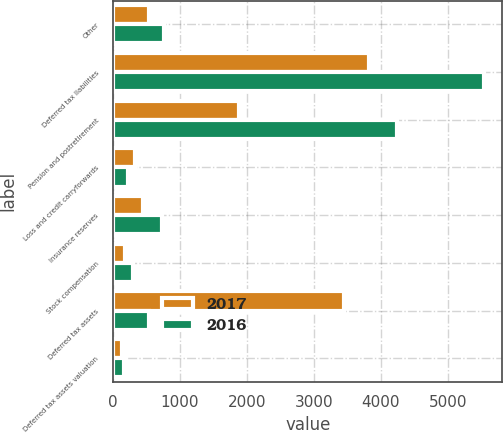Convert chart to OTSL. <chart><loc_0><loc_0><loc_500><loc_500><stacked_bar_chart><ecel><fcel>Other<fcel>Deferred tax liabilities<fcel>Pension and postretirement<fcel>Loss and credit carryforwards<fcel>Insurance reserves<fcel>Stock compensation<fcel>Deferred tax assets<fcel>Deferred tax assets valuation<nl><fcel>2017<fcel>535<fcel>3823<fcel>1877<fcel>323<fcel>449<fcel>182<fcel>3457<fcel>126<nl><fcel>2016<fcel>756<fcel>5538<fcel>4236<fcel>229<fcel>733<fcel>297<fcel>535<fcel>159<nl></chart> 